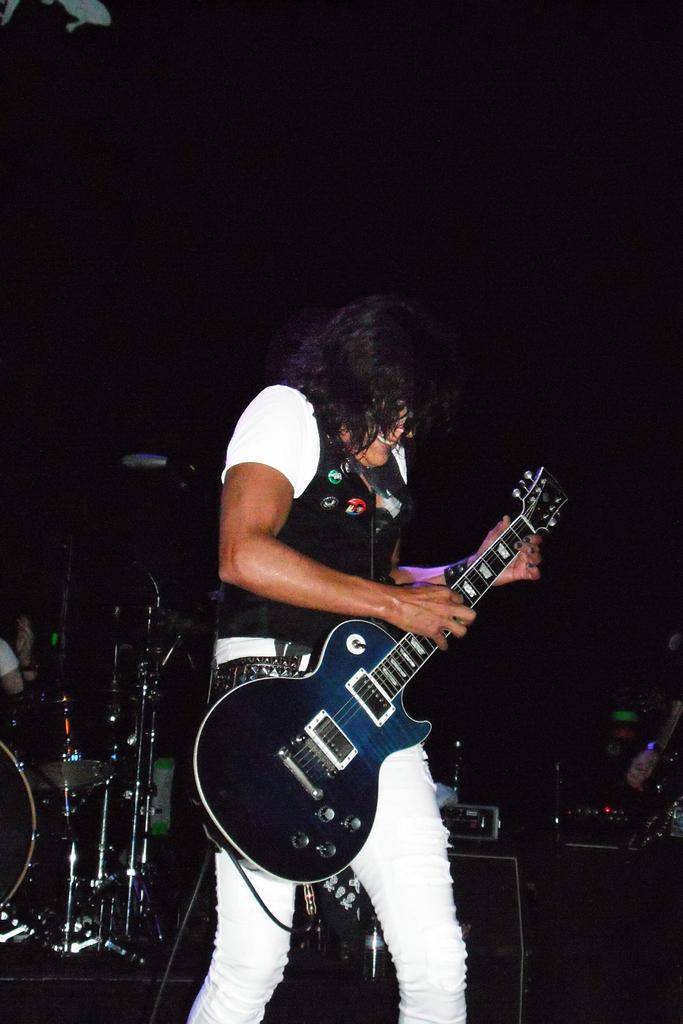Describe this image in one or two sentences. Man in middle of picture wearing black jacket and white jeans is holding guitar in his hands and playing it, and he is smiling. Behind him, we find many musical instruments and drums placed over there. I think he is performing in a program. 